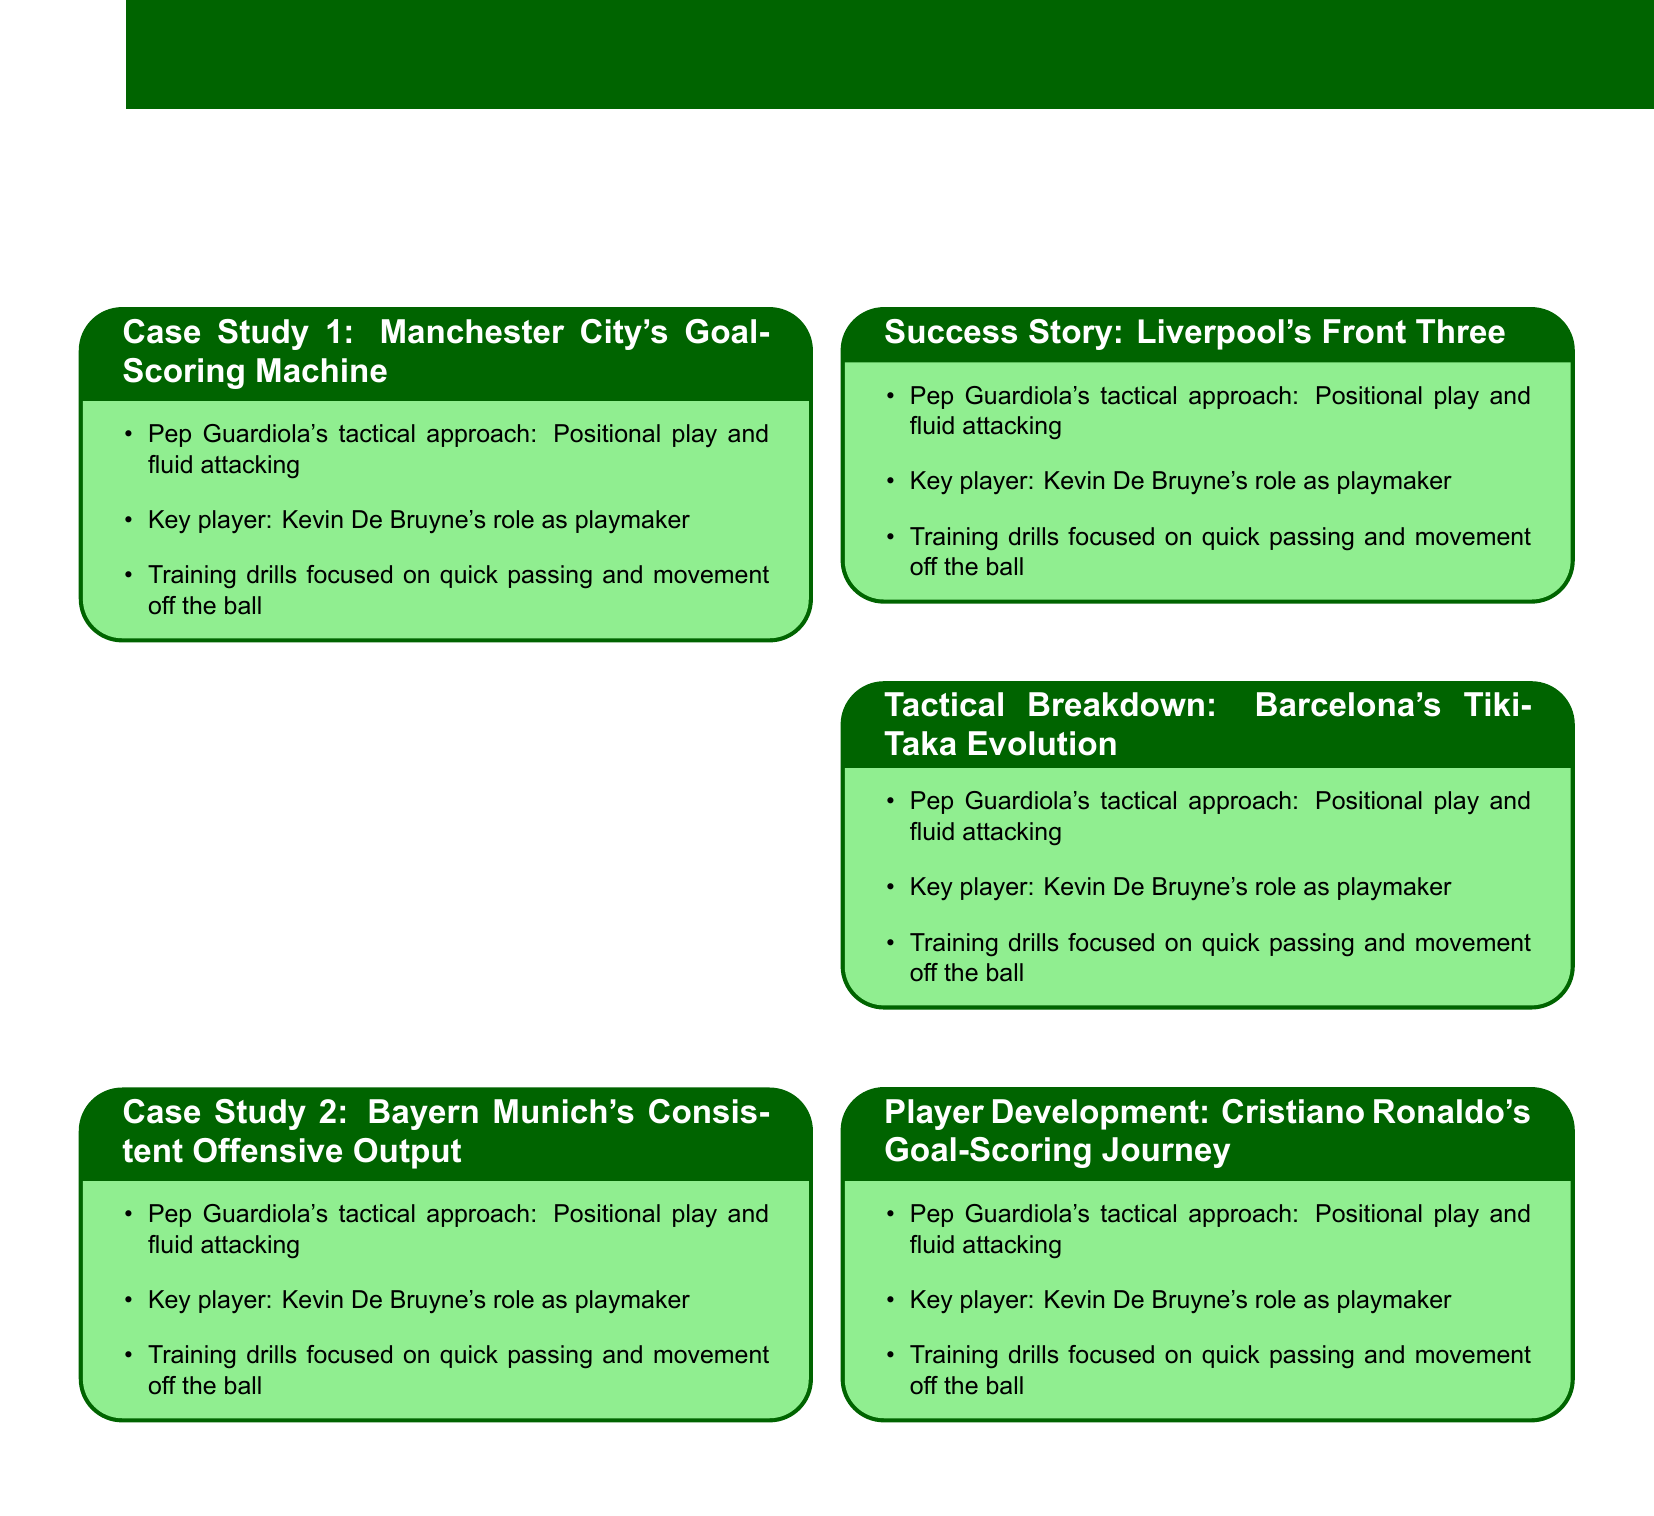What is the title of Case Study 1? The title of Case Study 1 is mentioned in the document as "Manchester City's Goal-Scoring Machine."
Answer: Manchester City's Goal-Scoring Machine Who is a key player discussed in Case Study 2? The document points out Robert Lewandowski as a key player in Case Study 2.
Answer: Robert Lewandowski What is the main tactical approach of Liverpool's Front Three? The document states that Jürgen Klopp's gegenpressing is the main approach discussed in the corresponding section.
Answer: gegenpressing Which team's evolution is analyzed in the Tactical Breakdown? The Tactical Breakdown focuses on the evolution of Barcelona's Tiki-Taka.
Answer: Barcelona's Tiki-Taka What player development is explored in the last section? The last section examines Cristiano Ronaldo's goal-scoring journey in player development.
Answer: Cristiano Ronaldo's goal-scoring journey What training focus is highlighted in Case Study 1? Case Study 1 emphasizes training drills focused on quick passing and movement off the ball.
Answer: Quick passing and movement off the ball How many case studies are documented? The document features a total of five case studies and success stories.
Answer: Five What role does Lionel Messi play according to the Tactical Breakdown? The Tactical Breakdown states that Lionel Messi's role is described as a false nine.
Answer: False nine What is Thomas Müller's tactical interpretation technique called? The document mentions that Thomas Müller's technique is called "Raumdeuter."
Answer: Raumdeuter 